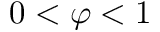Convert formula to latex. <formula><loc_0><loc_0><loc_500><loc_500>0 < \varphi < 1</formula> 